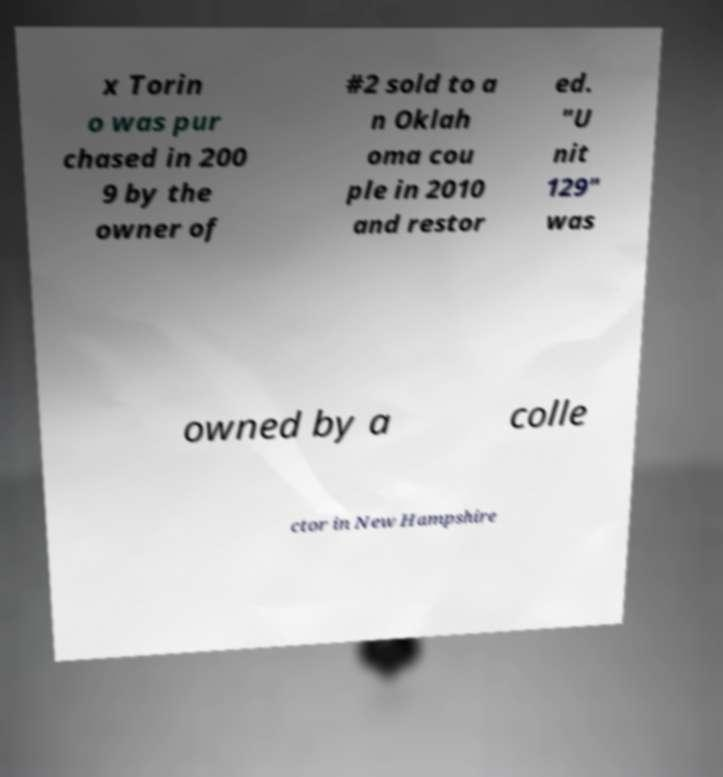Please read and relay the text visible in this image. What does it say? x Torin o was pur chased in 200 9 by the owner of #2 sold to a n Oklah oma cou ple in 2010 and restor ed. "U nit 129" was owned by a colle ctor in New Hampshire 